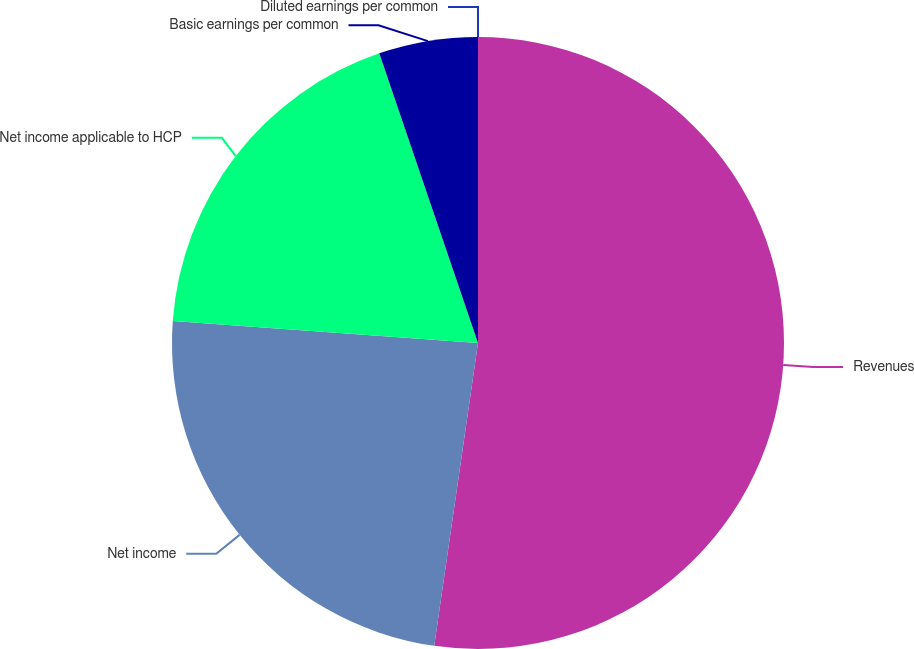Convert chart. <chart><loc_0><loc_0><loc_500><loc_500><pie_chart><fcel>Revenues<fcel>Net income<fcel>Net income applicable to HCP<fcel>Basic earnings per common<fcel>Diluted earnings per common<nl><fcel>52.29%<fcel>23.86%<fcel>18.63%<fcel>5.23%<fcel>0.0%<nl></chart> 